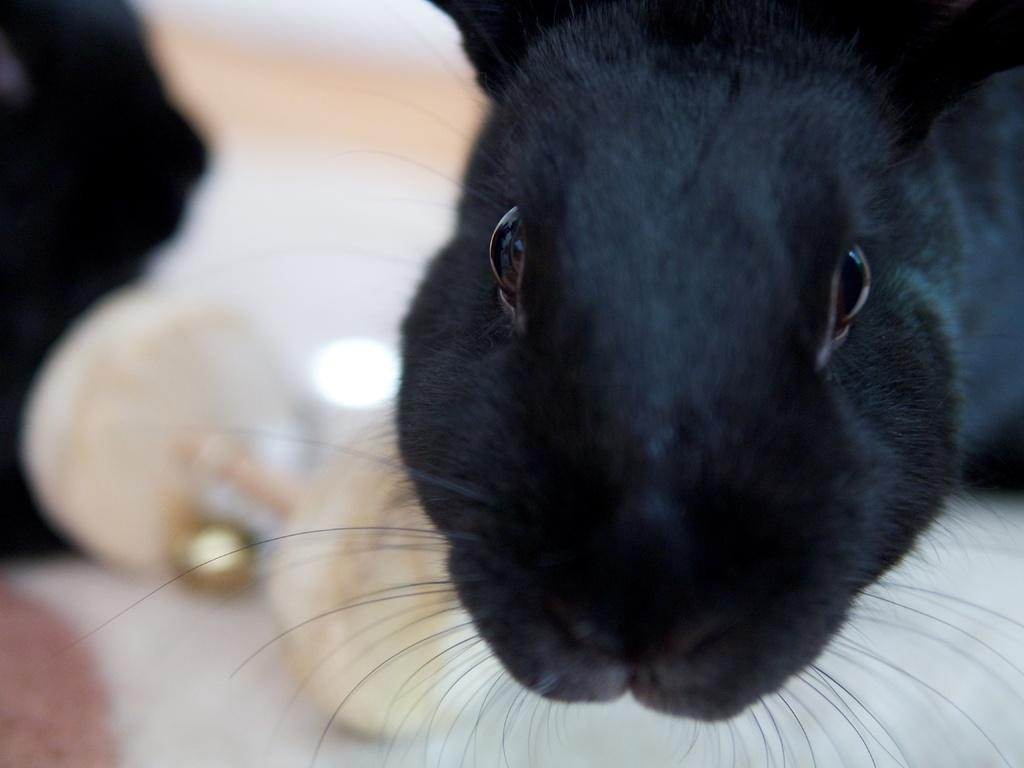What animal's face is depicted in the image? There is a black color rabbit's face in the image. Can you describe the color of the rabbit's face? The rabbit's face in the image is black. What type of gun is being used by the rabbit in the image? There is no gun present in the image; it features a rabbit's face. What kind of voyage is the rabbit embarking on in the image? There is no voyage depicted in the image; it features a rabbit's face. 